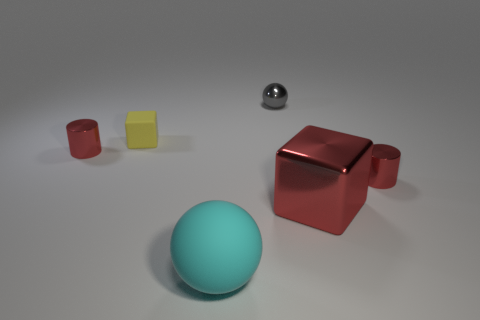How many other objects are there of the same material as the yellow block?
Make the answer very short. 1. Is the number of tiny yellow matte blocks that are in front of the tiny sphere less than the number of small blocks that are on the left side of the small yellow rubber block?
Your answer should be compact. No. What size is the red shiny cylinder left of the cyan matte thing?
Ensure brevity in your answer.  Small. Do the cyan sphere and the rubber block have the same size?
Keep it short and to the point. No. How many small objects are both in front of the yellow block and on the left side of the large cyan matte ball?
Ensure brevity in your answer.  1. How many yellow objects are either tiny things or matte cubes?
Offer a very short reply. 1. What number of shiny objects are either tiny cylinders or tiny objects?
Provide a succinct answer. 3. Is there a red rubber object?
Your answer should be compact. No. Is the shape of the large red metallic object the same as the yellow object?
Your answer should be compact. Yes. There is a cylinder that is in front of the red metallic thing on the left side of the large red cube; what number of tiny red metallic things are left of it?
Keep it short and to the point. 1. 